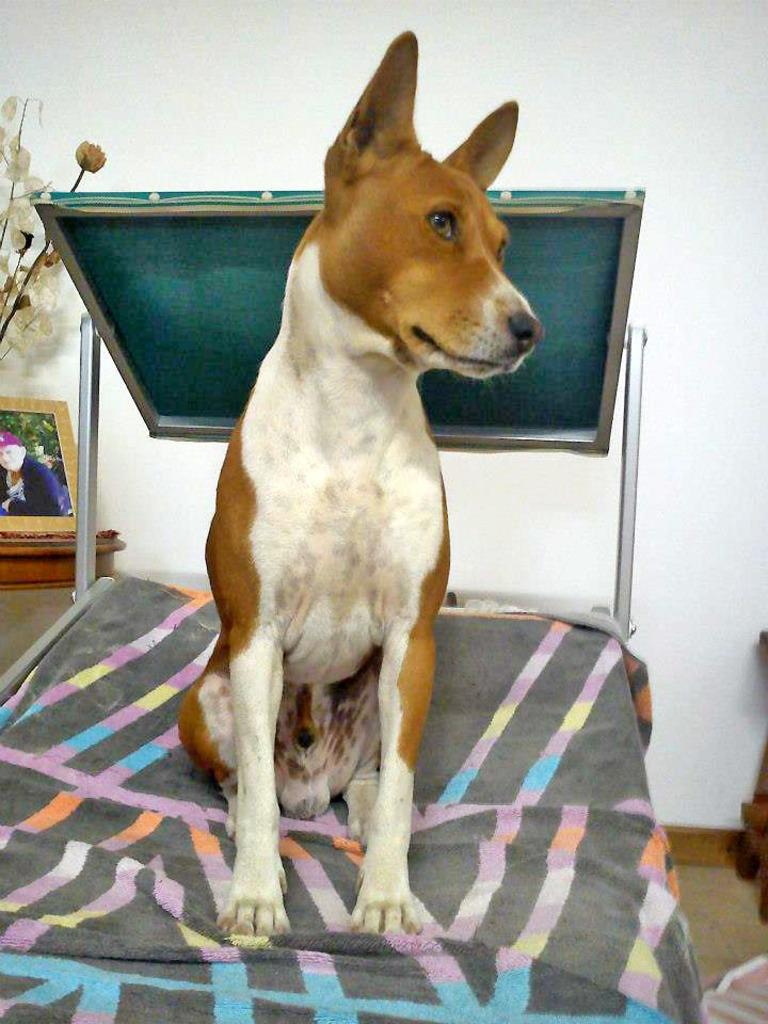What animal can be seen in the image? There is a dog in the image. What is the dog doing in the image? The dog is sitting on an object. What is located behind the dog in the image? There is a photo frame and a house plant behind the dog. What is the color of the wall behind the dog? There is a white wall behind the dog. Is the dog bleeding in the image? No, there is no indication of blood or injury on the dog in the image. Is the dog sleeping in the image? No, the dog is sitting in the image, not sleeping. 